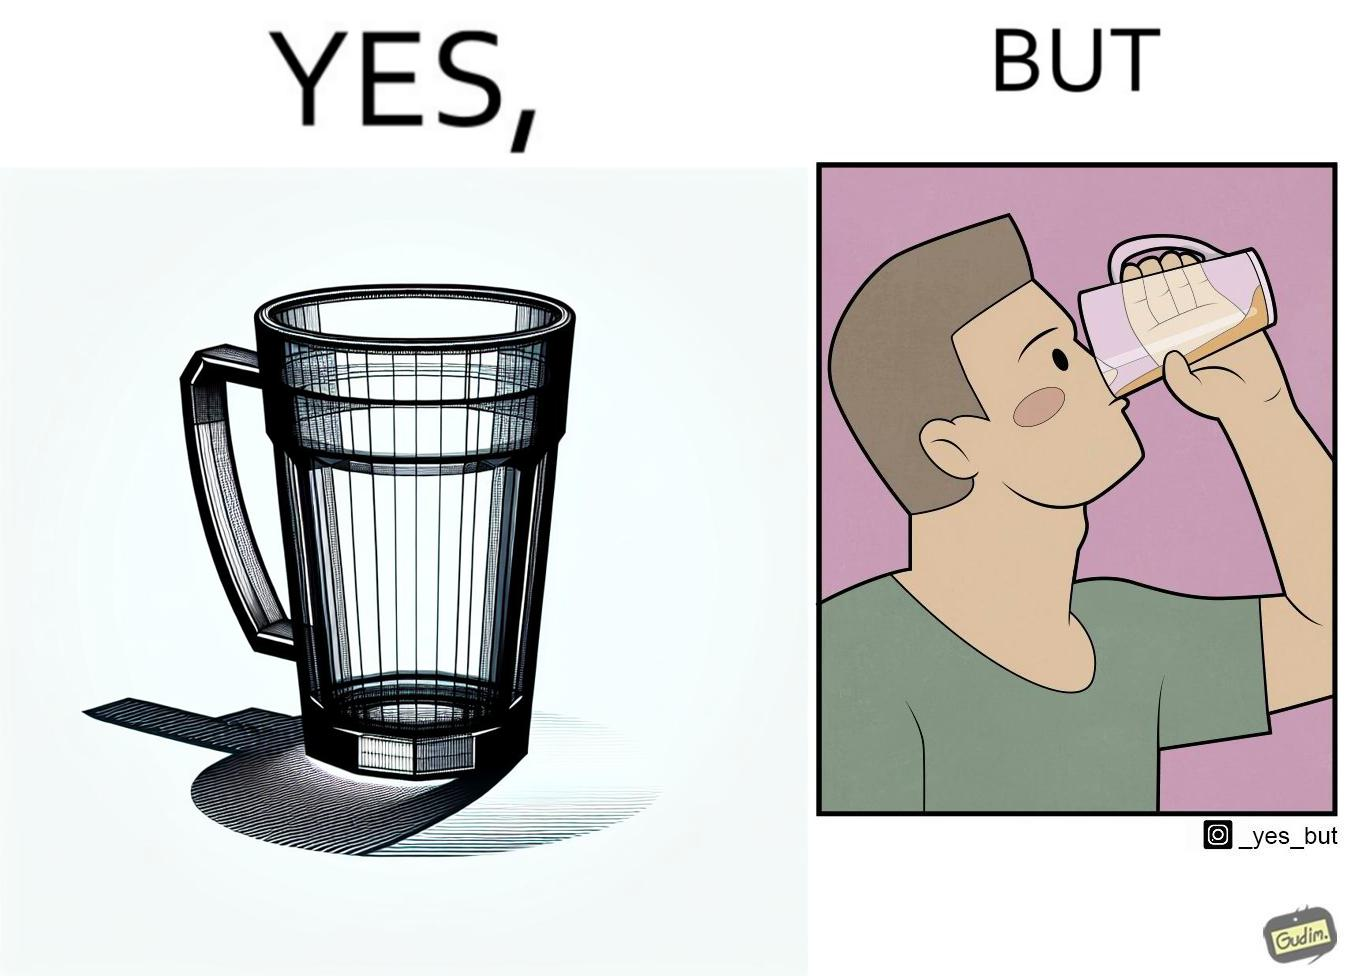What do you see in each half of this image? In the left part of the image: A transparent glass tumbler that has a glass handle on it In the right part of the image: A person drinking something from a glass tumbler. The tumbler has a handle on it. The person is not using the handle, but grabbing the tumbler directly. 